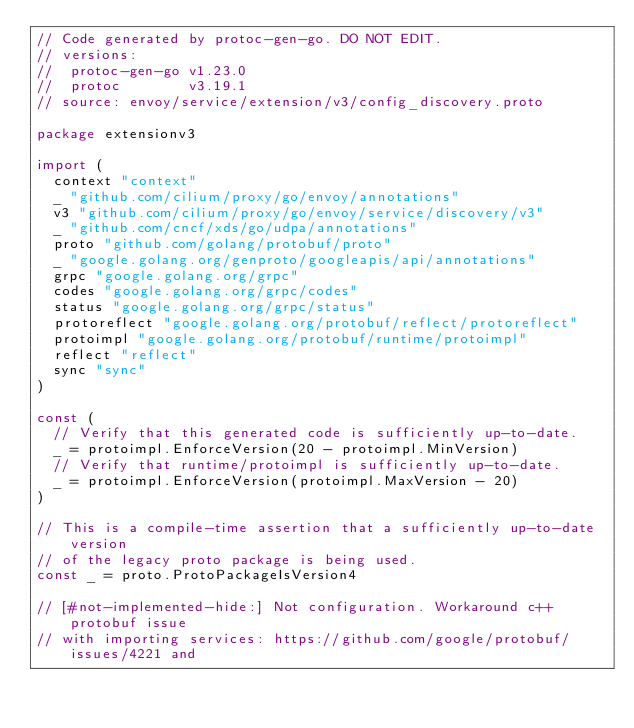Convert code to text. <code><loc_0><loc_0><loc_500><loc_500><_Go_>// Code generated by protoc-gen-go. DO NOT EDIT.
// versions:
// 	protoc-gen-go v1.23.0
// 	protoc        v3.19.1
// source: envoy/service/extension/v3/config_discovery.proto

package extensionv3

import (
	context "context"
	_ "github.com/cilium/proxy/go/envoy/annotations"
	v3 "github.com/cilium/proxy/go/envoy/service/discovery/v3"
	_ "github.com/cncf/xds/go/udpa/annotations"
	proto "github.com/golang/protobuf/proto"
	_ "google.golang.org/genproto/googleapis/api/annotations"
	grpc "google.golang.org/grpc"
	codes "google.golang.org/grpc/codes"
	status "google.golang.org/grpc/status"
	protoreflect "google.golang.org/protobuf/reflect/protoreflect"
	protoimpl "google.golang.org/protobuf/runtime/protoimpl"
	reflect "reflect"
	sync "sync"
)

const (
	// Verify that this generated code is sufficiently up-to-date.
	_ = protoimpl.EnforceVersion(20 - protoimpl.MinVersion)
	// Verify that runtime/protoimpl is sufficiently up-to-date.
	_ = protoimpl.EnforceVersion(protoimpl.MaxVersion - 20)
)

// This is a compile-time assertion that a sufficiently up-to-date version
// of the legacy proto package is being used.
const _ = proto.ProtoPackageIsVersion4

// [#not-implemented-hide:] Not configuration. Workaround c++ protobuf issue
// with importing services: https://github.com/google/protobuf/issues/4221 and</code> 